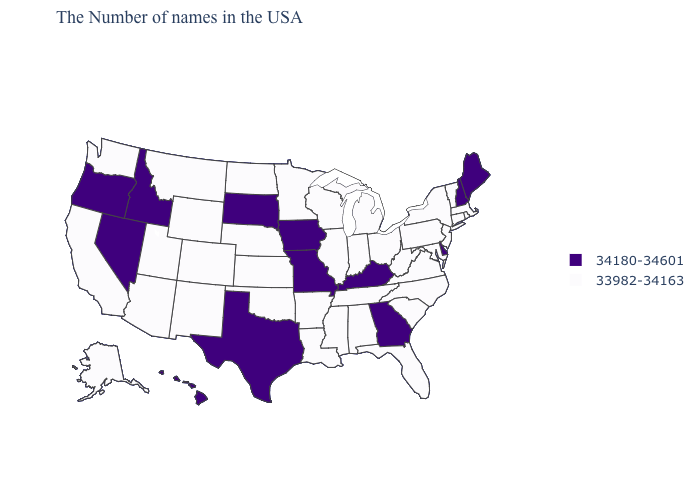What is the value of Utah?
Short answer required. 33982-34163. Does the first symbol in the legend represent the smallest category?
Short answer required. No. What is the value of Hawaii?
Give a very brief answer. 34180-34601. Among the states that border Colorado , which have the highest value?
Give a very brief answer. Kansas, Nebraska, Oklahoma, Wyoming, New Mexico, Utah, Arizona. Name the states that have a value in the range 34180-34601?
Be succinct. Maine, New Hampshire, Delaware, Georgia, Kentucky, Missouri, Iowa, Texas, South Dakota, Idaho, Nevada, Oregon, Hawaii. What is the value of Oklahoma?
Short answer required. 33982-34163. What is the value of Oregon?
Answer briefly. 34180-34601. Name the states that have a value in the range 34180-34601?
Short answer required. Maine, New Hampshire, Delaware, Georgia, Kentucky, Missouri, Iowa, Texas, South Dakota, Idaho, Nevada, Oregon, Hawaii. What is the highest value in states that border Virginia?
Concise answer only. 34180-34601. How many symbols are there in the legend?
Answer briefly. 2. What is the value of Ohio?
Answer briefly. 33982-34163. What is the lowest value in states that border Utah?
Answer briefly. 33982-34163. How many symbols are there in the legend?
Answer briefly. 2. What is the value of Wisconsin?
Quick response, please. 33982-34163. What is the value of Arkansas?
Be succinct. 33982-34163. 